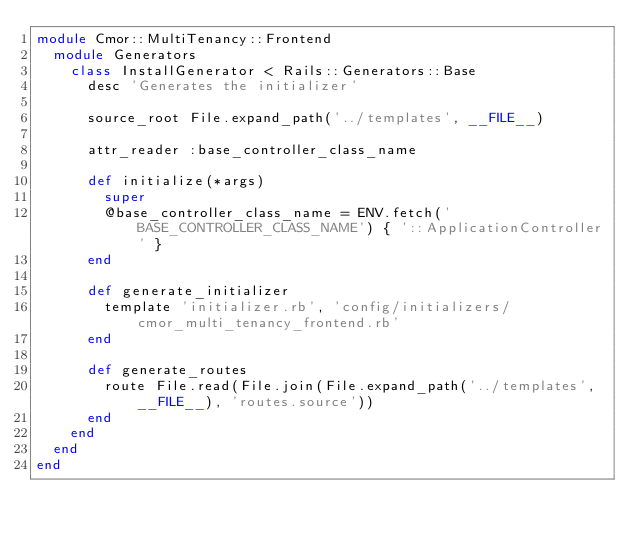Convert code to text. <code><loc_0><loc_0><loc_500><loc_500><_Ruby_>module Cmor::MultiTenancy::Frontend
  module Generators
    class InstallGenerator < Rails::Generators::Base
      desc 'Generates the initializer'

      source_root File.expand_path('../templates', __FILE__)

      attr_reader :base_controller_class_name

      def initialize(*args)
        super
        @base_controller_class_name = ENV.fetch('BASE_CONTROLLER_CLASS_NAME') { '::ApplicationController' }
      end

      def generate_initializer
        template 'initializer.rb', 'config/initializers/cmor_multi_tenancy_frontend.rb'
      end

      def generate_routes
        route File.read(File.join(File.expand_path('../templates', __FILE__), 'routes.source'))
      end
    end
  end
end

</code> 